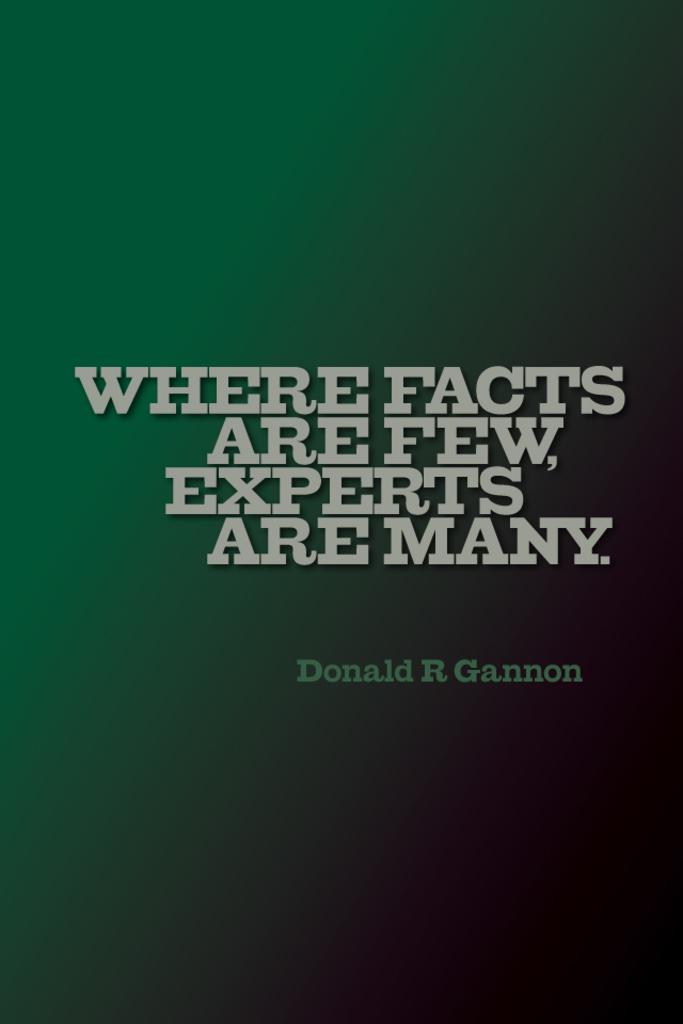<image>
Offer a succinct explanation of the picture presented. Donald R Gannon said, "Where facts are few, Experts are many." 